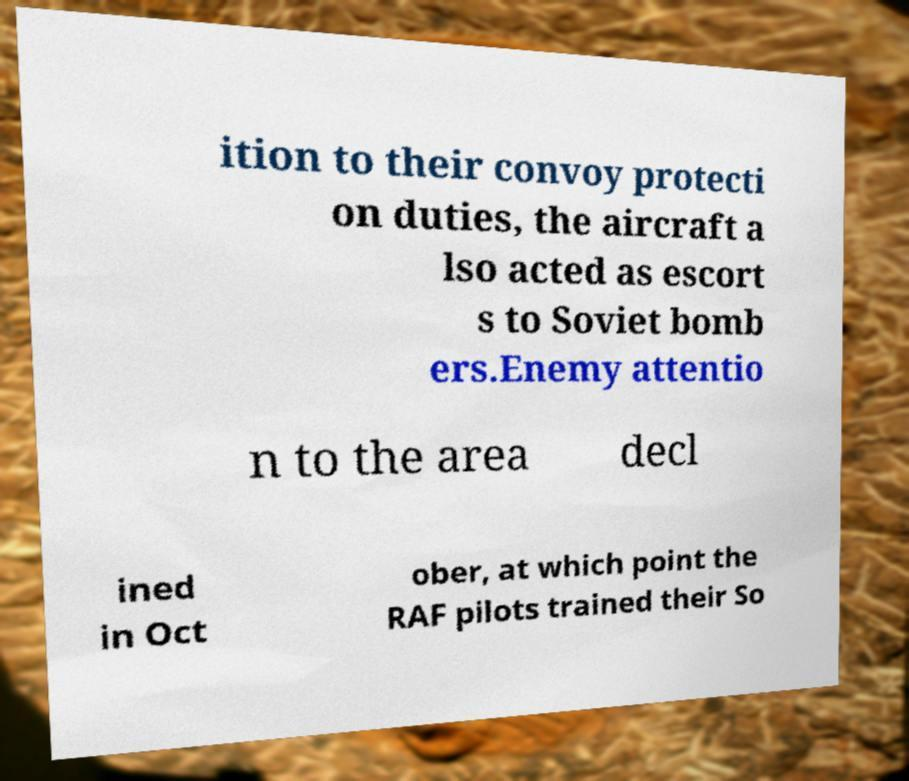Could you assist in decoding the text presented in this image and type it out clearly? ition to their convoy protecti on duties, the aircraft a lso acted as escort s to Soviet bomb ers.Enemy attentio n to the area decl ined in Oct ober, at which point the RAF pilots trained their So 